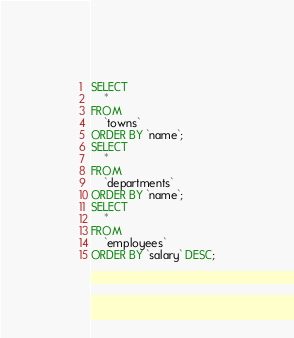Convert code to text. <code><loc_0><loc_0><loc_500><loc_500><_SQL_>SELECT 
    *
FROM
    `towns`
ORDER BY `name`;
SELECT 
    *
FROM
    `departments`
ORDER BY `name`;
SELECT 
    *
FROM
    `employees`
ORDER BY `salary` DESC;</code> 